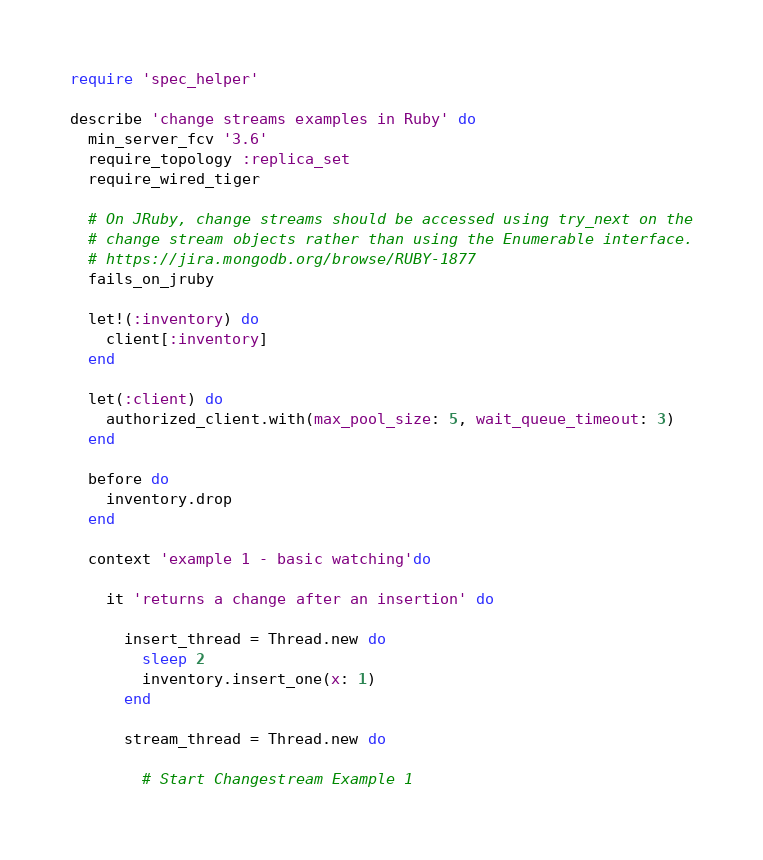<code> <loc_0><loc_0><loc_500><loc_500><_Ruby_>require 'spec_helper'

describe 'change streams examples in Ruby' do
  min_server_fcv '3.6'
  require_topology :replica_set
  require_wired_tiger

  # On JRuby, change streams should be accessed using try_next on the
  # change stream objects rather than using the Enumerable interface.
  # https://jira.mongodb.org/browse/RUBY-1877
  fails_on_jruby

  let!(:inventory) do
    client[:inventory]
  end

  let(:client) do
    authorized_client.with(max_pool_size: 5, wait_queue_timeout: 3)
  end

  before do
    inventory.drop
  end

  context 'example 1 - basic watching'do

    it 'returns a change after an insertion' do

      insert_thread = Thread.new do
        sleep 2
        inventory.insert_one(x: 1)
      end

      stream_thread = Thread.new do

        # Start Changestream Example 1
</code> 